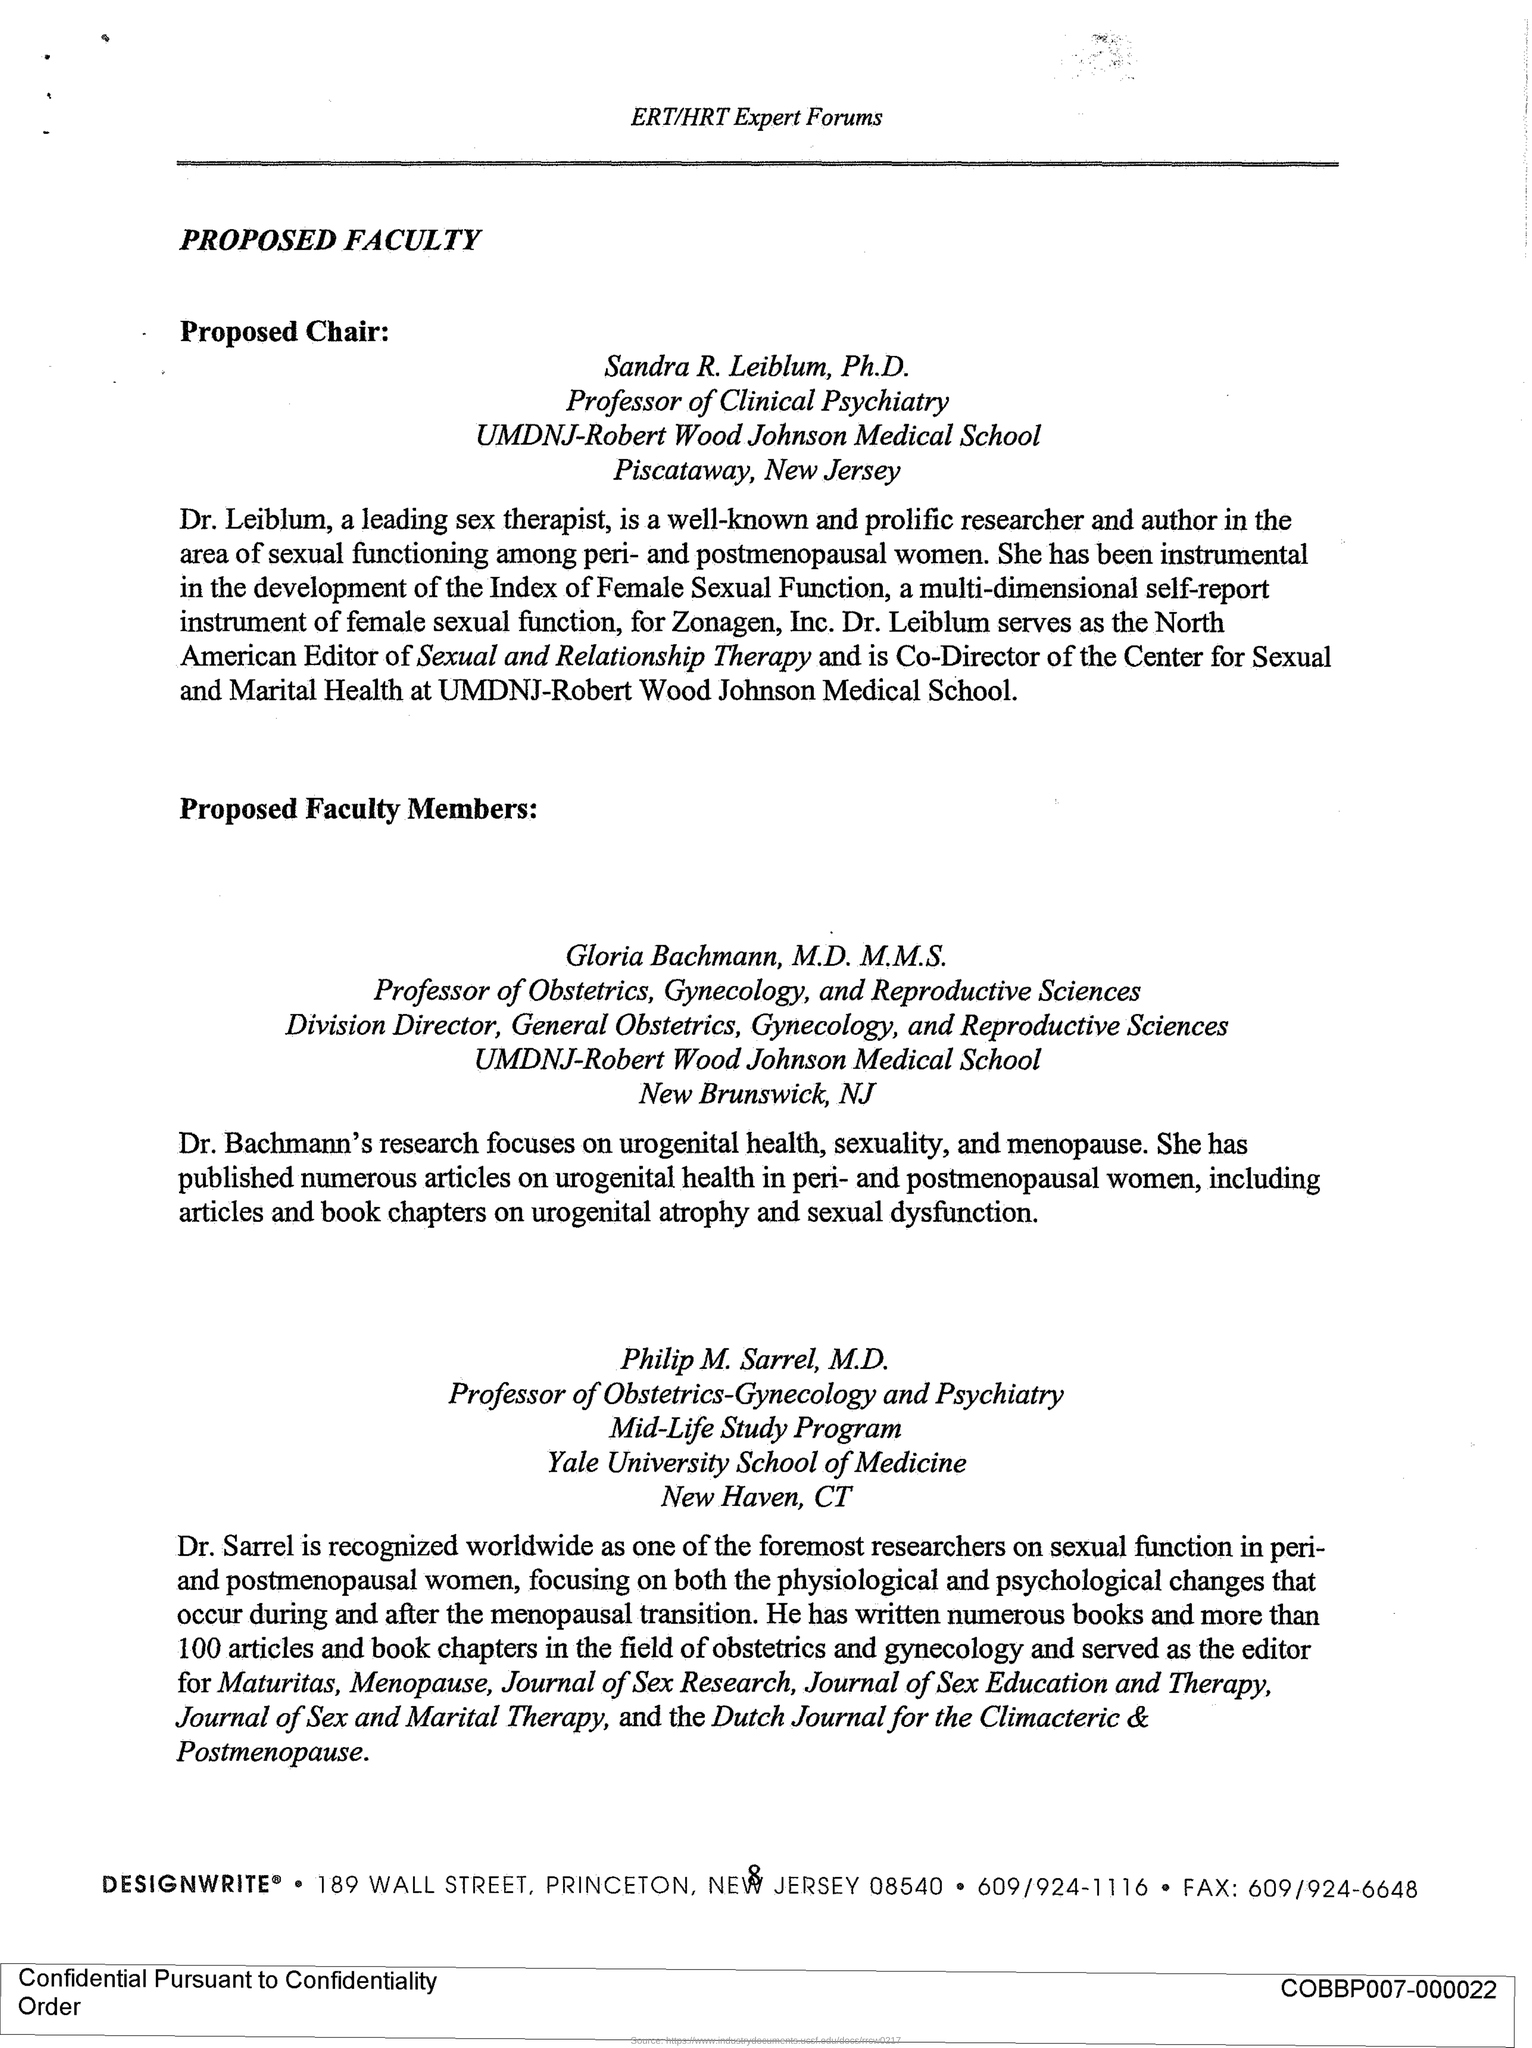Draw attention to some important aspects in this diagram. The page number is 8," the speaker declared. PROPOSED FACULTY... is the first title in the document. 